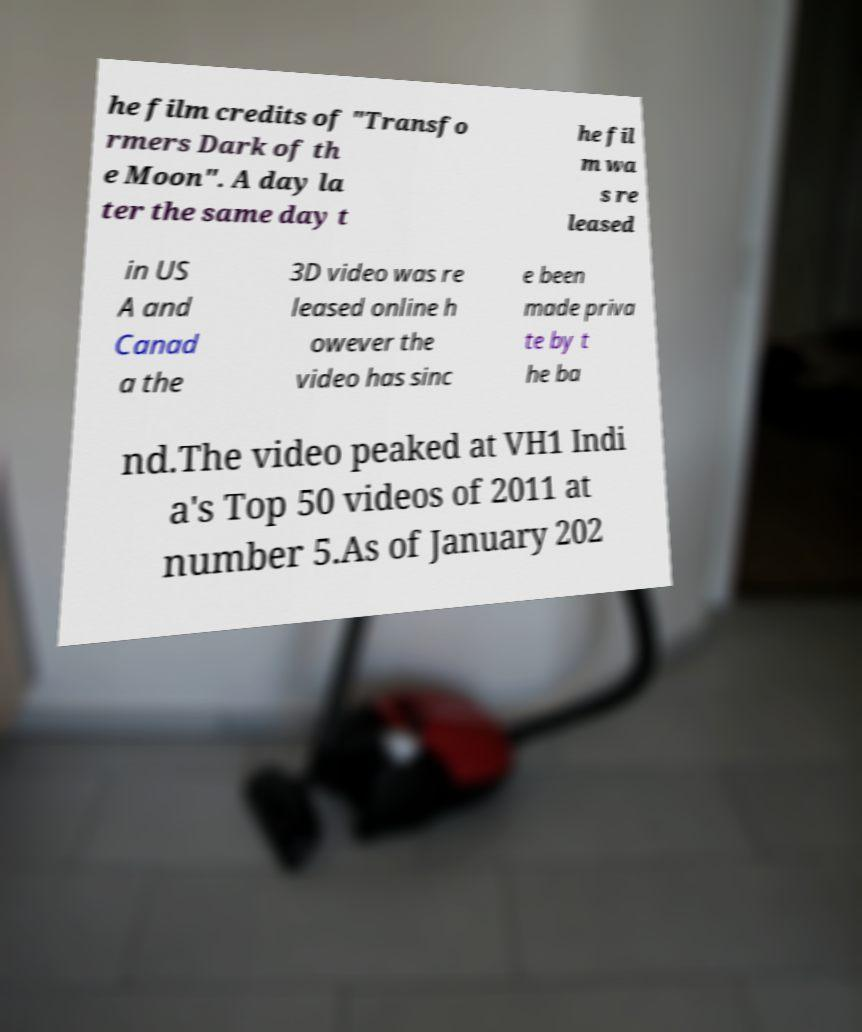Can you accurately transcribe the text from the provided image for me? he film credits of "Transfo rmers Dark of th e Moon". A day la ter the same day t he fil m wa s re leased in US A and Canad a the 3D video was re leased online h owever the video has sinc e been made priva te by t he ba nd.The video peaked at VH1 Indi a's Top 50 videos of 2011 at number 5.As of January 202 